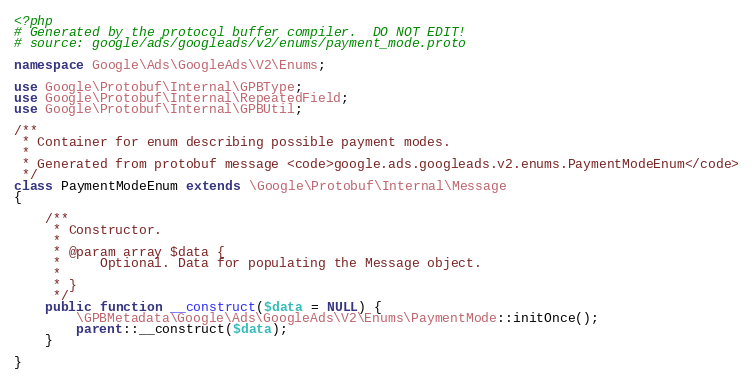<code> <loc_0><loc_0><loc_500><loc_500><_PHP_><?php
# Generated by the protocol buffer compiler.  DO NOT EDIT!
# source: google/ads/googleads/v2/enums/payment_mode.proto

namespace Google\Ads\GoogleAds\V2\Enums;

use Google\Protobuf\Internal\GPBType;
use Google\Protobuf\Internal\RepeatedField;
use Google\Protobuf\Internal\GPBUtil;

/**
 * Container for enum describing possible payment modes.
 *
 * Generated from protobuf message <code>google.ads.googleads.v2.enums.PaymentModeEnum</code>
 */
class PaymentModeEnum extends \Google\Protobuf\Internal\Message
{

    /**
     * Constructor.
     *
     * @param array $data {
     *     Optional. Data for populating the Message object.
     *
     * }
     */
    public function __construct($data = NULL) {
        \GPBMetadata\Google\Ads\GoogleAds\V2\Enums\PaymentMode::initOnce();
        parent::__construct($data);
    }

}

</code> 